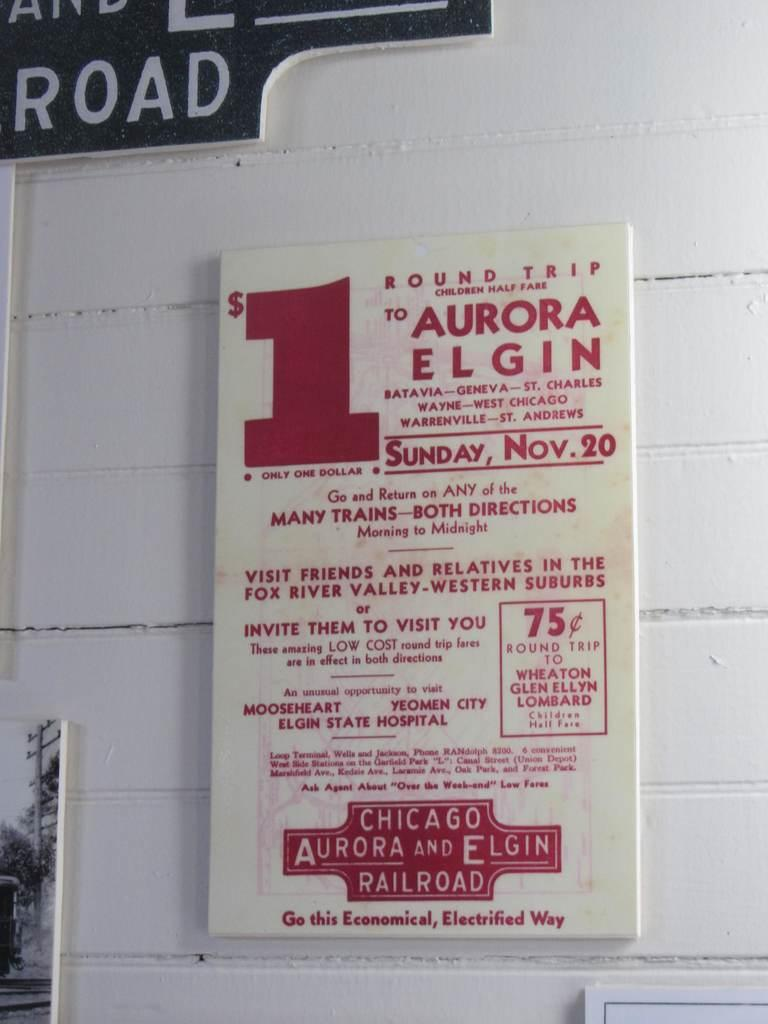<image>
Write a terse but informative summary of the picture. A railroad flyer advertising a one dollar round trip. 